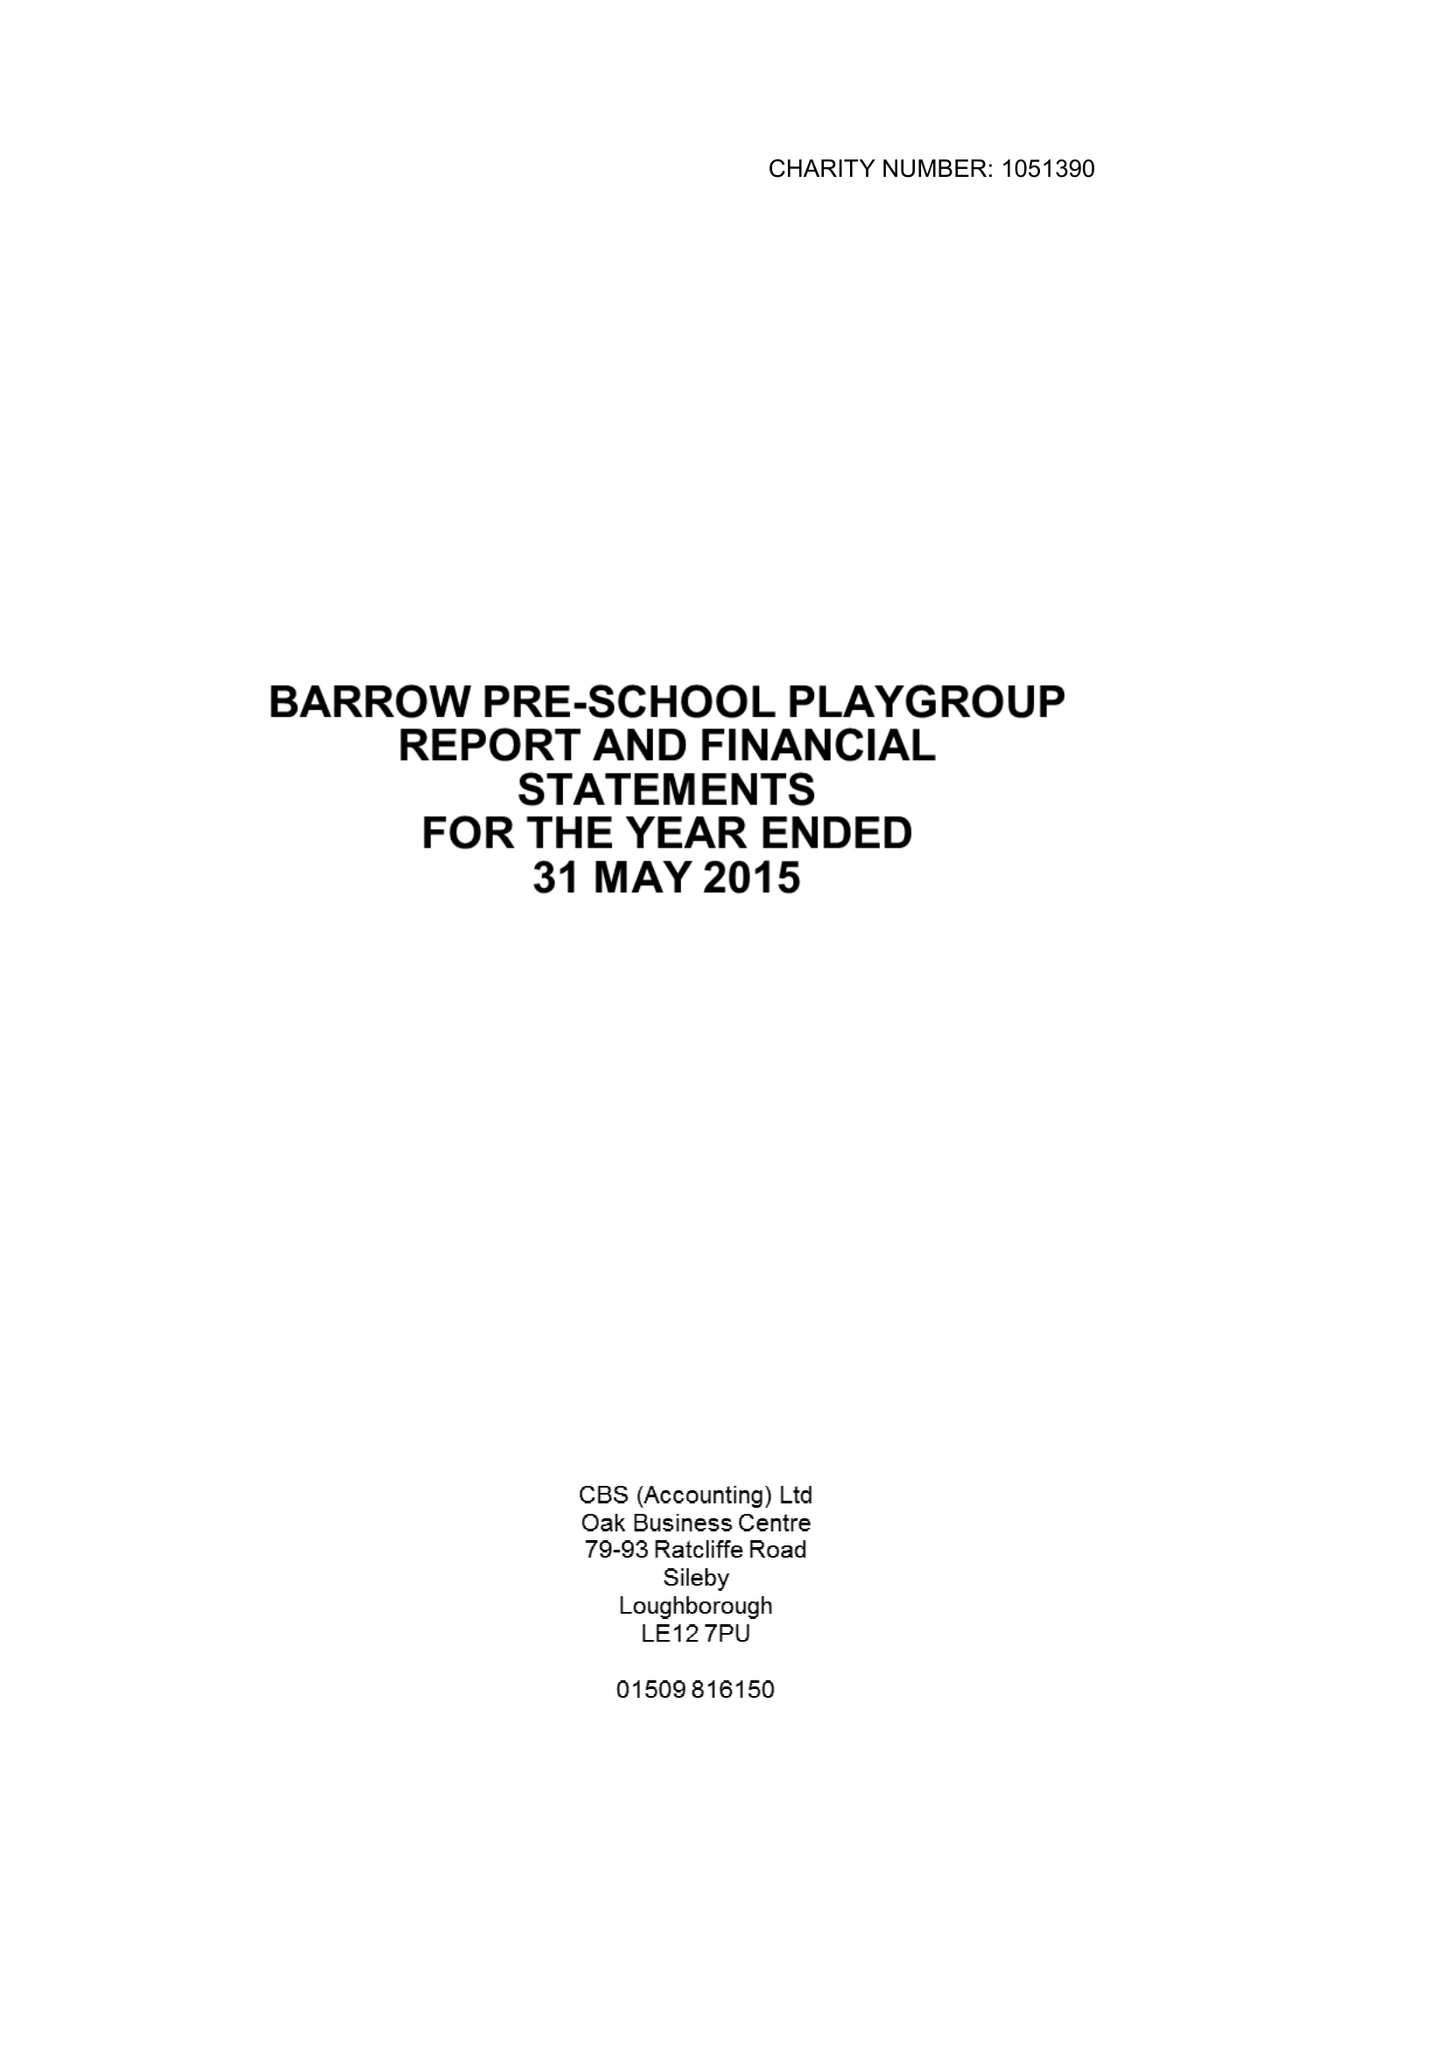What is the value for the income_annually_in_british_pounds?
Answer the question using a single word or phrase. 66954.00 